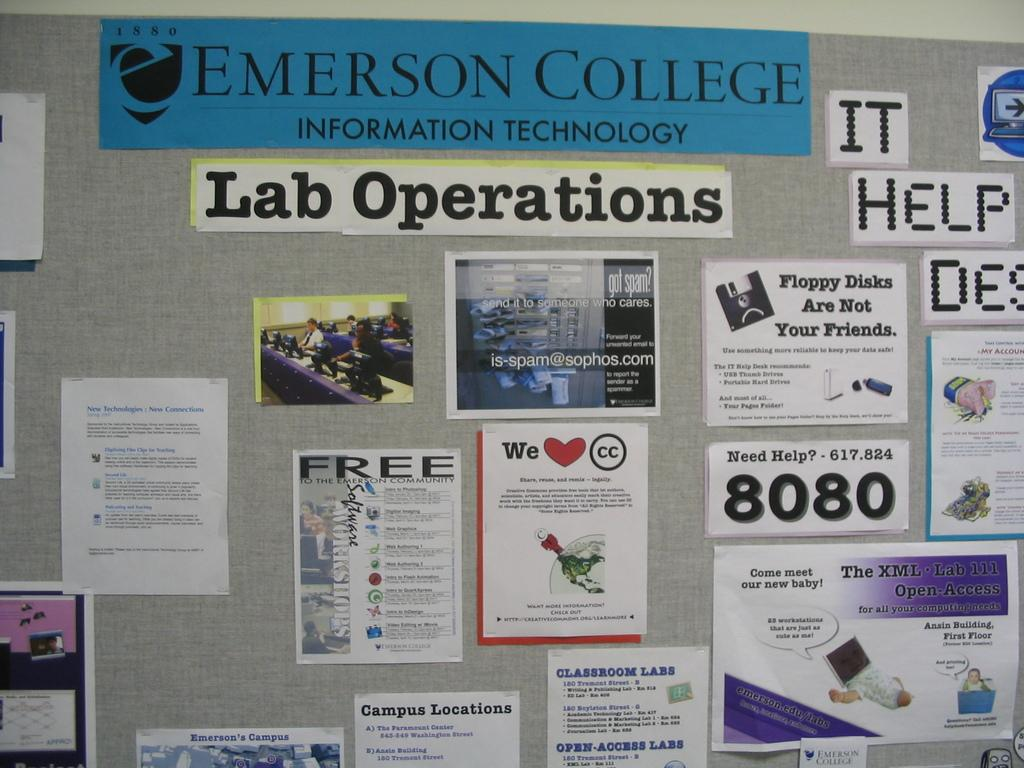<image>
Offer a succinct explanation of the picture presented. A bulletin board for Emerson College has lab operations information. 